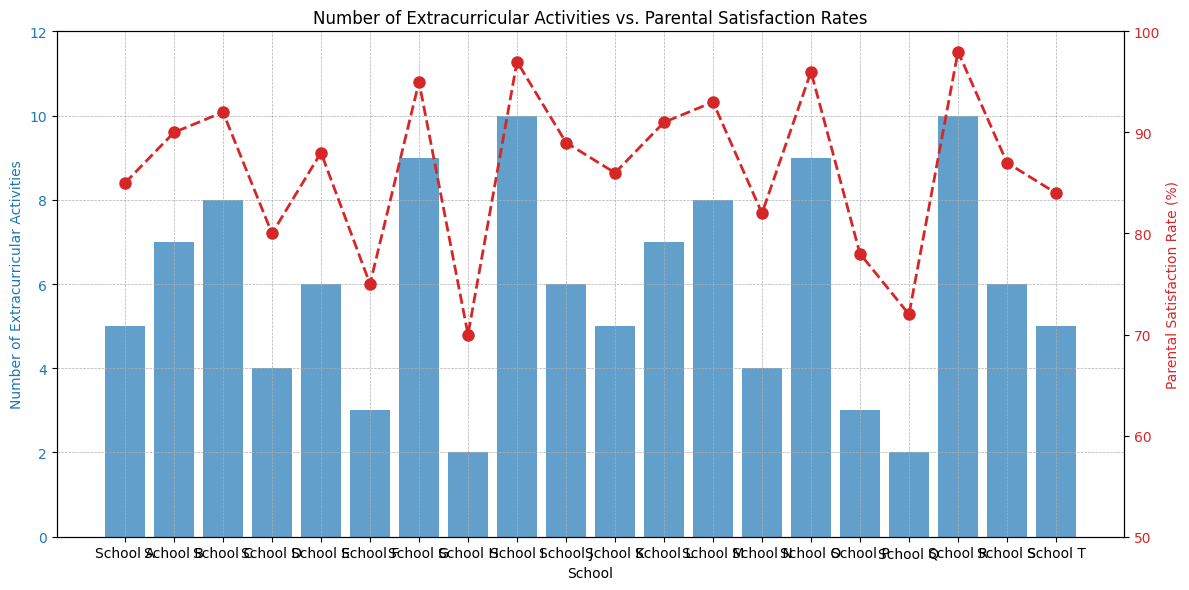What's the average number of extracurricular activities across all schools? Add up the total number of extracurricular activities of all schools (5 + 7 + 8 + 4 + 6 + 3 + 9 + 2 + 10 + 6 + 5 + 7 + 8 + 4 + 9 + 3 + 2 + 10 + 6 + 5) = 127 and divide by the number of schools, which is 20. Therefore, the average is 127 / 20 = 6.35
Answer: 6.35 Which school has the highest parental satisfaction rate and what is the rate? Look at the red markers (line chart) and identify the highest point on the y-axis (Parental Satisfaction Rate). The school with the highest rate is School R with a rate of 98%.
Answer: School R, 98% Is there a school with more than 6 extracurricular activities that has a parental satisfaction rate below 90%? Check the blue bars corresponding to schools with more than 6 extracurricular activities and then cross-reference with their parental satisfaction rates (red markers). Both School C and School M have extracurricular activities more than 6 (8) but their satisfaction rates are above 90% (92% and 93%). Hence, no such school exists.
Answer: No What is the difference in parental satisfaction rates between School A and School H? The parental satisfaction rate for School A is 85% and for School H is 70%. The difference is 85 - 70 = 15%.
Answer: 15% Which school has the least number of extracurricular activities and what is its parental satisfaction rate? Look for the shortest blue bar which represents the number of extracurricular activities; School H and School Q both have the least with 2 extracurricular activities. Their parental satisfaction rates are 70% and 72% respectively.
Answer: School H, 70% Compare the number of extracurricular activities and parental satisfaction rates for School G and School O. School G has 9 extracurricular activities with a parental satisfaction rate of 95%. School O also has 9 extracurricular activities but has a slightly higher parental satisfaction rate of 96%.
Answer: School G: 9, 95%; School O: 9, 96% On average, do schools with 6 extracurricular activities have higher parental satisfaction rates than those with 5? Identify the schools with 6 extracurricular activities (School E, School J, School S) and calculate their average satisfaction rate (88 + 89 + 87) / 3 = 88%. Identify the schools with 5 extracurricular activities (School A, School K, School T) and calculate their average satisfaction rate (85 + 86 + 84) / 3 = 85%. Compare the two averages.
Answer: Yes What is the standard deviation of parental satisfaction rates across all schools? Calculate the mean parental satisfaction rate, then for each school, find the squared difference from the mean, average those squared differences, and take the square root of that average. Using the data provided: Mean = 85.9, Variance = 53.64, Standard Deviation = √53.64 ≈ 7.32
Answer: 7.32 Which schools have exactly 7 extracurricular activities and how do their parental satisfaction rates compare? Identify the schools with exactly 7 extracurricular activities which are School B and School L. Compare their parental satisfaction rates: School B (90%), School L (91%).
Answer: School B: 90%; School L: 91% 